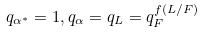<formula> <loc_0><loc_0><loc_500><loc_500>q _ { \alpha ^ { * } } = 1 , q _ { \alpha } = q _ { L } = q _ { F } ^ { f ( L / F ) }</formula> 